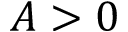<formula> <loc_0><loc_0><loc_500><loc_500>A > 0</formula> 